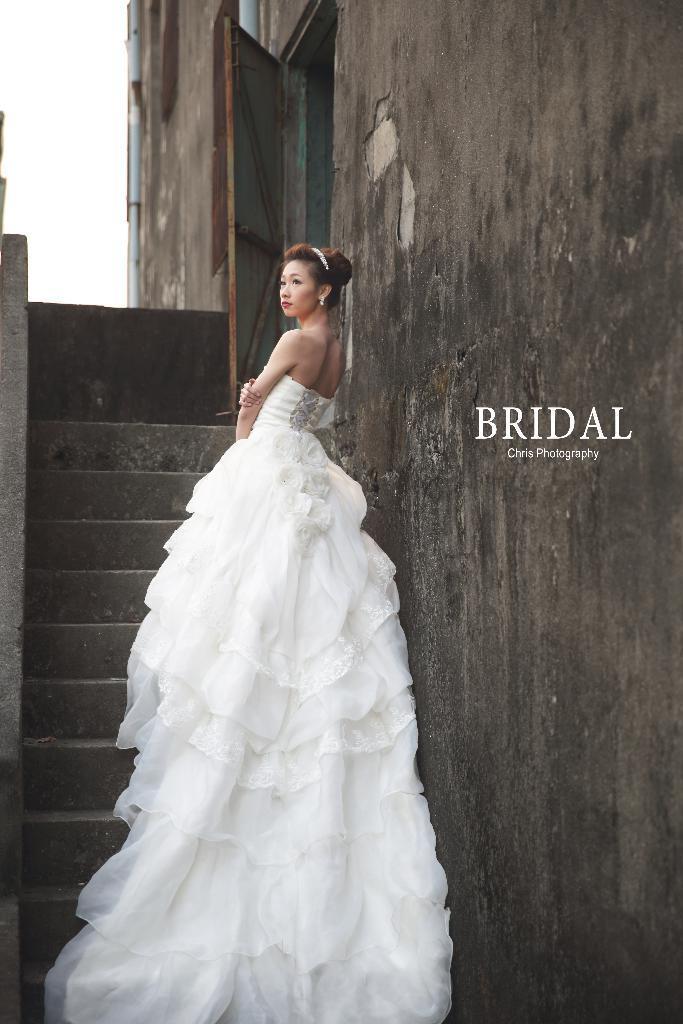Describe this image in one or two sentences. In this image I can see a woman standing on staircase and I can see the wall on the right side and I can see a text , in the top left I can see the sky and door visible in the middle. 